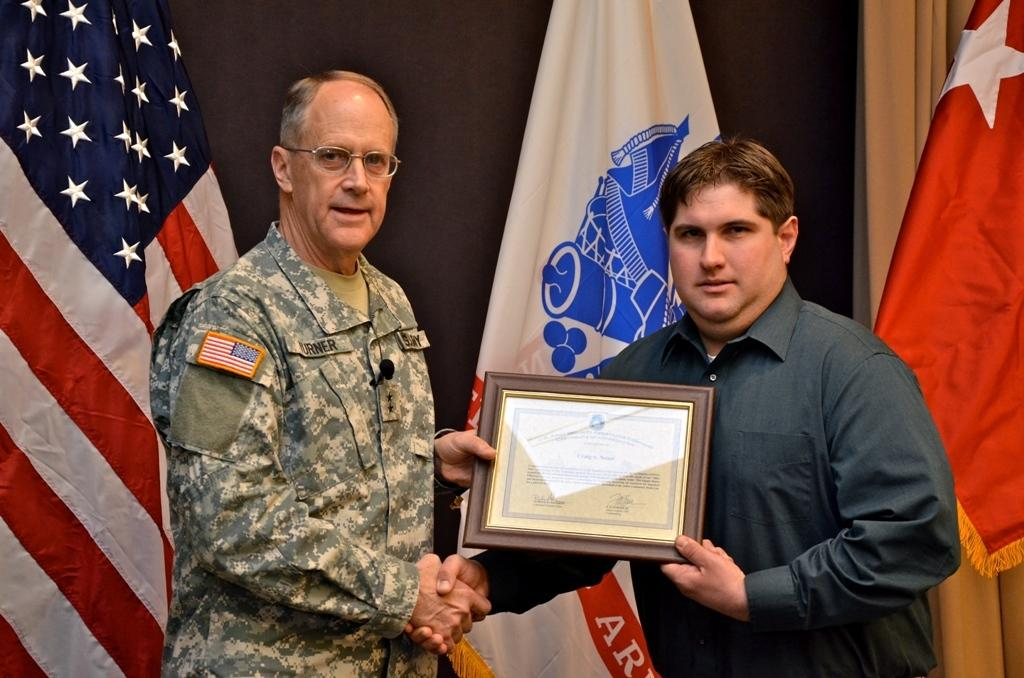How many people are in the image? There are two men in the image. What are the men doing in the image? Both men are standing in the image. What are the men wearing? Both men are wearing clothes. Can you describe the appearance of the man on the left side? The man on the left side is wearing spectacles. What are the men holding in the image? The men are holding a frame. What can be seen in the background of the image? There are flags of countries visible in the background. What type of crime is being committed in the image? There is no crime being committed in the image; it features two men standing and holding a frame. What thrilling activity are the men participating in? There is no thrilling activity depicted in the image; the men are simply standing and holding a frame. 